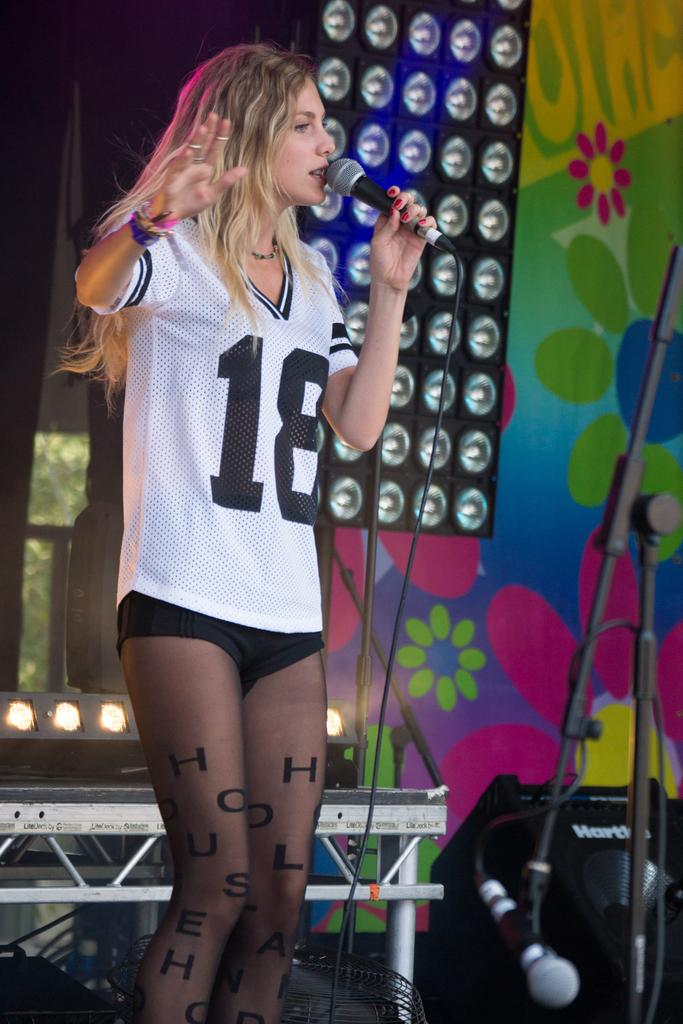<image>
Present a compact description of the photo's key features. a girl singing and wearing the number 18 on it 